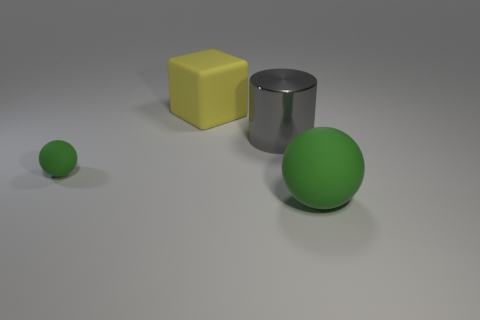How many green balls must be subtracted to get 1 green balls? 1 Add 4 matte cubes. How many objects exist? 8 Subtract all cylinders. How many objects are left? 3 Subtract all large green spheres. Subtract all large gray matte objects. How many objects are left? 3 Add 1 green matte balls. How many green matte balls are left? 3 Add 1 tiny green matte balls. How many tiny green matte balls exist? 2 Subtract 1 yellow blocks. How many objects are left? 3 